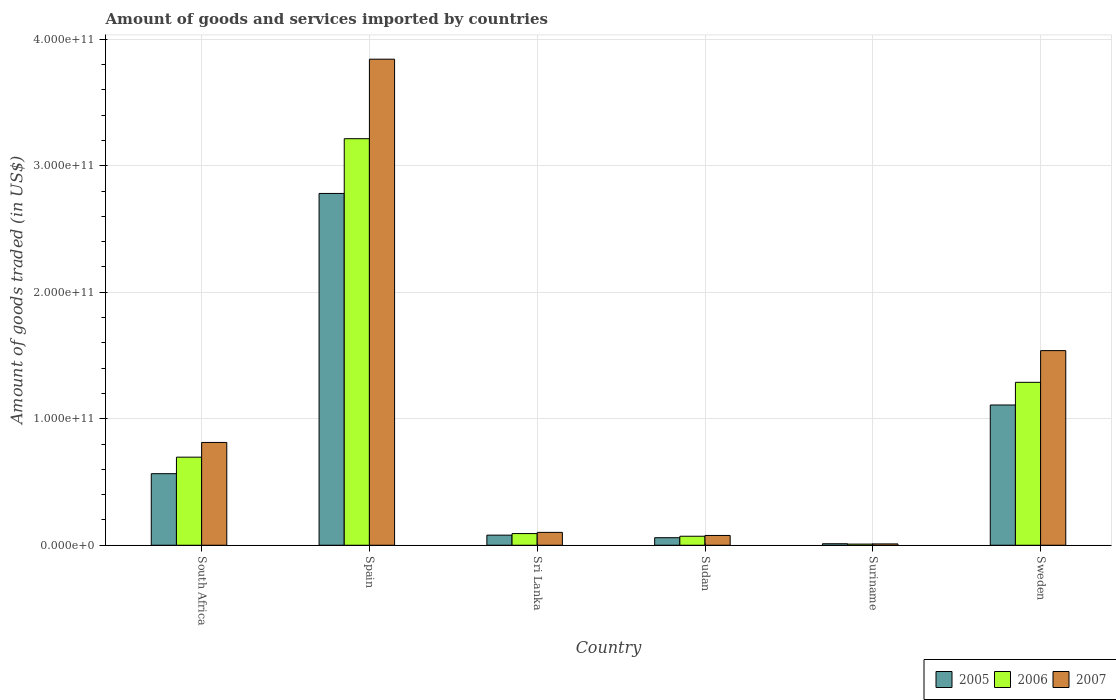Are the number of bars per tick equal to the number of legend labels?
Your answer should be very brief. Yes. How many bars are there on the 3rd tick from the left?
Provide a succinct answer. 3. What is the label of the 2nd group of bars from the left?
Offer a very short reply. Spain. In how many cases, is the number of bars for a given country not equal to the number of legend labels?
Give a very brief answer. 0. What is the total amount of goods and services imported in 2007 in Sudan?
Your answer should be very brief. 7.72e+09. Across all countries, what is the maximum total amount of goods and services imported in 2006?
Ensure brevity in your answer.  3.21e+11. Across all countries, what is the minimum total amount of goods and services imported in 2006?
Keep it short and to the point. 9.03e+08. In which country was the total amount of goods and services imported in 2005 minimum?
Ensure brevity in your answer.  Suriname. What is the total total amount of goods and services imported in 2005 in the graph?
Your answer should be compact. 4.61e+11. What is the difference between the total amount of goods and services imported in 2006 in Suriname and that in Sweden?
Your answer should be compact. -1.28e+11. What is the difference between the total amount of goods and services imported in 2007 in Suriname and the total amount of goods and services imported in 2005 in Sweden?
Your response must be concise. -1.10e+11. What is the average total amount of goods and services imported in 2006 per country?
Offer a very short reply. 8.95e+1. What is the difference between the total amount of goods and services imported of/in 2005 and total amount of goods and services imported of/in 2006 in Suriname?
Provide a short and direct response. 2.86e+08. What is the ratio of the total amount of goods and services imported in 2007 in South Africa to that in Sudan?
Your answer should be very brief. 10.52. Is the difference between the total amount of goods and services imported in 2005 in Sri Lanka and Sudan greater than the difference between the total amount of goods and services imported in 2006 in Sri Lanka and Sudan?
Give a very brief answer. No. What is the difference between the highest and the second highest total amount of goods and services imported in 2007?
Provide a succinct answer. 2.30e+11. What is the difference between the highest and the lowest total amount of goods and services imported in 2005?
Your answer should be very brief. 2.77e+11. In how many countries, is the total amount of goods and services imported in 2006 greater than the average total amount of goods and services imported in 2006 taken over all countries?
Make the answer very short. 2. Is the sum of the total amount of goods and services imported in 2005 in Sudan and Sweden greater than the maximum total amount of goods and services imported in 2006 across all countries?
Provide a short and direct response. No. What does the 2nd bar from the left in Sudan represents?
Provide a short and direct response. 2006. How many countries are there in the graph?
Give a very brief answer. 6. What is the difference between two consecutive major ticks on the Y-axis?
Give a very brief answer. 1.00e+11. Does the graph contain any zero values?
Your answer should be very brief. No. Does the graph contain grids?
Your answer should be very brief. Yes. How many legend labels are there?
Offer a very short reply. 3. How are the legend labels stacked?
Provide a succinct answer. Horizontal. What is the title of the graph?
Offer a terse response. Amount of goods and services imported by countries. What is the label or title of the Y-axis?
Offer a very short reply. Amount of goods traded (in US$). What is the Amount of goods traded (in US$) of 2005 in South Africa?
Offer a very short reply. 5.66e+1. What is the Amount of goods traded (in US$) of 2006 in South Africa?
Give a very brief answer. 6.96e+1. What is the Amount of goods traded (in US$) in 2007 in South Africa?
Your answer should be compact. 8.13e+1. What is the Amount of goods traded (in US$) in 2005 in Spain?
Provide a short and direct response. 2.78e+11. What is the Amount of goods traded (in US$) in 2006 in Spain?
Provide a succinct answer. 3.21e+11. What is the Amount of goods traded (in US$) in 2007 in Spain?
Give a very brief answer. 3.84e+11. What is the Amount of goods traded (in US$) in 2005 in Sri Lanka?
Offer a very short reply. 7.98e+09. What is the Amount of goods traded (in US$) in 2006 in Sri Lanka?
Offer a terse response. 9.23e+09. What is the Amount of goods traded (in US$) of 2007 in Sri Lanka?
Make the answer very short. 1.02e+1. What is the Amount of goods traded (in US$) of 2005 in Sudan?
Make the answer very short. 5.95e+09. What is the Amount of goods traded (in US$) of 2006 in Sudan?
Provide a succinct answer. 7.10e+09. What is the Amount of goods traded (in US$) in 2007 in Sudan?
Provide a succinct answer. 7.72e+09. What is the Amount of goods traded (in US$) in 2005 in Suriname?
Offer a very short reply. 1.19e+09. What is the Amount of goods traded (in US$) of 2006 in Suriname?
Make the answer very short. 9.03e+08. What is the Amount of goods traded (in US$) of 2007 in Suriname?
Your answer should be compact. 1.04e+09. What is the Amount of goods traded (in US$) in 2005 in Sweden?
Your answer should be compact. 1.11e+11. What is the Amount of goods traded (in US$) in 2006 in Sweden?
Offer a very short reply. 1.29e+11. What is the Amount of goods traded (in US$) of 2007 in Sweden?
Offer a very short reply. 1.54e+11. Across all countries, what is the maximum Amount of goods traded (in US$) in 2005?
Provide a succinct answer. 2.78e+11. Across all countries, what is the maximum Amount of goods traded (in US$) of 2006?
Provide a succinct answer. 3.21e+11. Across all countries, what is the maximum Amount of goods traded (in US$) in 2007?
Provide a succinct answer. 3.84e+11. Across all countries, what is the minimum Amount of goods traded (in US$) of 2005?
Your answer should be compact. 1.19e+09. Across all countries, what is the minimum Amount of goods traded (in US$) of 2006?
Provide a short and direct response. 9.03e+08. Across all countries, what is the minimum Amount of goods traded (in US$) of 2007?
Provide a short and direct response. 1.04e+09. What is the total Amount of goods traded (in US$) of 2005 in the graph?
Offer a very short reply. 4.61e+11. What is the total Amount of goods traded (in US$) of 2006 in the graph?
Give a very brief answer. 5.37e+11. What is the total Amount of goods traded (in US$) in 2007 in the graph?
Offer a very short reply. 6.38e+11. What is the difference between the Amount of goods traded (in US$) in 2005 in South Africa and that in Spain?
Provide a short and direct response. -2.22e+11. What is the difference between the Amount of goods traded (in US$) in 2006 in South Africa and that in Spain?
Your response must be concise. -2.52e+11. What is the difference between the Amount of goods traded (in US$) of 2007 in South Africa and that in Spain?
Provide a succinct answer. -3.03e+11. What is the difference between the Amount of goods traded (in US$) in 2005 in South Africa and that in Sri Lanka?
Provide a short and direct response. 4.86e+1. What is the difference between the Amount of goods traded (in US$) in 2006 in South Africa and that in Sri Lanka?
Your answer should be compact. 6.04e+1. What is the difference between the Amount of goods traded (in US$) in 2007 in South Africa and that in Sri Lanka?
Your answer should be very brief. 7.11e+1. What is the difference between the Amount of goods traded (in US$) of 2005 in South Africa and that in Sudan?
Provide a succinct answer. 5.06e+1. What is the difference between the Amount of goods traded (in US$) in 2006 in South Africa and that in Sudan?
Your answer should be very brief. 6.25e+1. What is the difference between the Amount of goods traded (in US$) of 2007 in South Africa and that in Sudan?
Offer a terse response. 7.35e+1. What is the difference between the Amount of goods traded (in US$) of 2005 in South Africa and that in Suriname?
Provide a short and direct response. 5.54e+1. What is the difference between the Amount of goods traded (in US$) in 2006 in South Africa and that in Suriname?
Make the answer very short. 6.87e+1. What is the difference between the Amount of goods traded (in US$) of 2007 in South Africa and that in Suriname?
Make the answer very short. 8.02e+1. What is the difference between the Amount of goods traded (in US$) of 2005 in South Africa and that in Sweden?
Keep it short and to the point. -5.43e+1. What is the difference between the Amount of goods traded (in US$) in 2006 in South Africa and that in Sweden?
Offer a very short reply. -5.92e+1. What is the difference between the Amount of goods traded (in US$) of 2007 in South Africa and that in Sweden?
Ensure brevity in your answer.  -7.26e+1. What is the difference between the Amount of goods traded (in US$) in 2005 in Spain and that in Sri Lanka?
Your answer should be compact. 2.70e+11. What is the difference between the Amount of goods traded (in US$) in 2006 in Spain and that in Sri Lanka?
Keep it short and to the point. 3.12e+11. What is the difference between the Amount of goods traded (in US$) of 2007 in Spain and that in Sri Lanka?
Provide a succinct answer. 3.74e+11. What is the difference between the Amount of goods traded (in US$) in 2005 in Spain and that in Sudan?
Your answer should be compact. 2.72e+11. What is the difference between the Amount of goods traded (in US$) in 2006 in Spain and that in Sudan?
Ensure brevity in your answer.  3.14e+11. What is the difference between the Amount of goods traded (in US$) of 2007 in Spain and that in Sudan?
Your response must be concise. 3.77e+11. What is the difference between the Amount of goods traded (in US$) in 2005 in Spain and that in Suriname?
Offer a terse response. 2.77e+11. What is the difference between the Amount of goods traded (in US$) of 2006 in Spain and that in Suriname?
Ensure brevity in your answer.  3.20e+11. What is the difference between the Amount of goods traded (in US$) in 2007 in Spain and that in Suriname?
Your response must be concise. 3.83e+11. What is the difference between the Amount of goods traded (in US$) of 2005 in Spain and that in Sweden?
Keep it short and to the point. 1.67e+11. What is the difference between the Amount of goods traded (in US$) in 2006 in Spain and that in Sweden?
Ensure brevity in your answer.  1.93e+11. What is the difference between the Amount of goods traded (in US$) of 2007 in Spain and that in Sweden?
Keep it short and to the point. 2.30e+11. What is the difference between the Amount of goods traded (in US$) of 2005 in Sri Lanka and that in Sudan?
Make the answer very short. 2.03e+09. What is the difference between the Amount of goods traded (in US$) in 2006 in Sri Lanka and that in Sudan?
Offer a very short reply. 2.12e+09. What is the difference between the Amount of goods traded (in US$) of 2007 in Sri Lanka and that in Sudan?
Your answer should be very brief. 2.44e+09. What is the difference between the Amount of goods traded (in US$) of 2005 in Sri Lanka and that in Suriname?
Keep it short and to the point. 6.79e+09. What is the difference between the Amount of goods traded (in US$) of 2006 in Sri Lanka and that in Suriname?
Your answer should be very brief. 8.33e+09. What is the difference between the Amount of goods traded (in US$) of 2007 in Sri Lanka and that in Suriname?
Make the answer very short. 9.12e+09. What is the difference between the Amount of goods traded (in US$) of 2005 in Sri Lanka and that in Sweden?
Offer a very short reply. -1.03e+11. What is the difference between the Amount of goods traded (in US$) of 2006 in Sri Lanka and that in Sweden?
Offer a very short reply. -1.20e+11. What is the difference between the Amount of goods traded (in US$) in 2007 in Sri Lanka and that in Sweden?
Make the answer very short. -1.44e+11. What is the difference between the Amount of goods traded (in US$) in 2005 in Sudan and that in Suriname?
Your answer should be very brief. 4.76e+09. What is the difference between the Amount of goods traded (in US$) of 2006 in Sudan and that in Suriname?
Provide a succinct answer. 6.20e+09. What is the difference between the Amount of goods traded (in US$) in 2007 in Sudan and that in Suriname?
Your answer should be compact. 6.68e+09. What is the difference between the Amount of goods traded (in US$) in 2005 in Sudan and that in Sweden?
Keep it short and to the point. -1.05e+11. What is the difference between the Amount of goods traded (in US$) of 2006 in Sudan and that in Sweden?
Offer a very short reply. -1.22e+11. What is the difference between the Amount of goods traded (in US$) in 2007 in Sudan and that in Sweden?
Your response must be concise. -1.46e+11. What is the difference between the Amount of goods traded (in US$) in 2005 in Suriname and that in Sweden?
Offer a terse response. -1.10e+11. What is the difference between the Amount of goods traded (in US$) of 2006 in Suriname and that in Sweden?
Your answer should be very brief. -1.28e+11. What is the difference between the Amount of goods traded (in US$) in 2007 in Suriname and that in Sweden?
Ensure brevity in your answer.  -1.53e+11. What is the difference between the Amount of goods traded (in US$) in 2005 in South Africa and the Amount of goods traded (in US$) in 2006 in Spain?
Offer a terse response. -2.65e+11. What is the difference between the Amount of goods traded (in US$) in 2005 in South Africa and the Amount of goods traded (in US$) in 2007 in Spain?
Offer a very short reply. -3.28e+11. What is the difference between the Amount of goods traded (in US$) of 2006 in South Africa and the Amount of goods traded (in US$) of 2007 in Spain?
Keep it short and to the point. -3.15e+11. What is the difference between the Amount of goods traded (in US$) of 2005 in South Africa and the Amount of goods traded (in US$) of 2006 in Sri Lanka?
Provide a succinct answer. 4.73e+1. What is the difference between the Amount of goods traded (in US$) in 2005 in South Africa and the Amount of goods traded (in US$) in 2007 in Sri Lanka?
Provide a succinct answer. 4.64e+1. What is the difference between the Amount of goods traded (in US$) in 2006 in South Africa and the Amount of goods traded (in US$) in 2007 in Sri Lanka?
Your answer should be very brief. 5.95e+1. What is the difference between the Amount of goods traded (in US$) of 2005 in South Africa and the Amount of goods traded (in US$) of 2006 in Sudan?
Your answer should be compact. 4.95e+1. What is the difference between the Amount of goods traded (in US$) in 2005 in South Africa and the Amount of goods traded (in US$) in 2007 in Sudan?
Ensure brevity in your answer.  4.88e+1. What is the difference between the Amount of goods traded (in US$) in 2006 in South Africa and the Amount of goods traded (in US$) in 2007 in Sudan?
Your response must be concise. 6.19e+1. What is the difference between the Amount of goods traded (in US$) of 2005 in South Africa and the Amount of goods traded (in US$) of 2006 in Suriname?
Give a very brief answer. 5.57e+1. What is the difference between the Amount of goods traded (in US$) of 2005 in South Africa and the Amount of goods traded (in US$) of 2007 in Suriname?
Offer a very short reply. 5.55e+1. What is the difference between the Amount of goods traded (in US$) of 2006 in South Africa and the Amount of goods traded (in US$) of 2007 in Suriname?
Offer a terse response. 6.86e+1. What is the difference between the Amount of goods traded (in US$) of 2005 in South Africa and the Amount of goods traded (in US$) of 2006 in Sweden?
Offer a very short reply. -7.22e+1. What is the difference between the Amount of goods traded (in US$) in 2005 in South Africa and the Amount of goods traded (in US$) in 2007 in Sweden?
Give a very brief answer. -9.73e+1. What is the difference between the Amount of goods traded (in US$) in 2006 in South Africa and the Amount of goods traded (in US$) in 2007 in Sweden?
Your answer should be compact. -8.42e+1. What is the difference between the Amount of goods traded (in US$) of 2005 in Spain and the Amount of goods traded (in US$) of 2006 in Sri Lanka?
Provide a short and direct response. 2.69e+11. What is the difference between the Amount of goods traded (in US$) in 2005 in Spain and the Amount of goods traded (in US$) in 2007 in Sri Lanka?
Offer a very short reply. 2.68e+11. What is the difference between the Amount of goods traded (in US$) in 2006 in Spain and the Amount of goods traded (in US$) in 2007 in Sri Lanka?
Provide a short and direct response. 3.11e+11. What is the difference between the Amount of goods traded (in US$) in 2005 in Spain and the Amount of goods traded (in US$) in 2006 in Sudan?
Your answer should be very brief. 2.71e+11. What is the difference between the Amount of goods traded (in US$) in 2005 in Spain and the Amount of goods traded (in US$) in 2007 in Sudan?
Keep it short and to the point. 2.70e+11. What is the difference between the Amount of goods traded (in US$) of 2006 in Spain and the Amount of goods traded (in US$) of 2007 in Sudan?
Provide a short and direct response. 3.14e+11. What is the difference between the Amount of goods traded (in US$) in 2005 in Spain and the Amount of goods traded (in US$) in 2006 in Suriname?
Ensure brevity in your answer.  2.77e+11. What is the difference between the Amount of goods traded (in US$) in 2005 in Spain and the Amount of goods traded (in US$) in 2007 in Suriname?
Your response must be concise. 2.77e+11. What is the difference between the Amount of goods traded (in US$) of 2006 in Spain and the Amount of goods traded (in US$) of 2007 in Suriname?
Provide a succinct answer. 3.20e+11. What is the difference between the Amount of goods traded (in US$) of 2005 in Spain and the Amount of goods traded (in US$) of 2006 in Sweden?
Your response must be concise. 1.49e+11. What is the difference between the Amount of goods traded (in US$) of 2005 in Spain and the Amount of goods traded (in US$) of 2007 in Sweden?
Ensure brevity in your answer.  1.24e+11. What is the difference between the Amount of goods traded (in US$) in 2006 in Spain and the Amount of goods traded (in US$) in 2007 in Sweden?
Offer a terse response. 1.68e+11. What is the difference between the Amount of goods traded (in US$) in 2005 in Sri Lanka and the Amount of goods traded (in US$) in 2006 in Sudan?
Offer a very short reply. 8.72e+08. What is the difference between the Amount of goods traded (in US$) of 2005 in Sri Lanka and the Amount of goods traded (in US$) of 2007 in Sudan?
Provide a succinct answer. 2.54e+08. What is the difference between the Amount of goods traded (in US$) of 2006 in Sri Lanka and the Amount of goods traded (in US$) of 2007 in Sudan?
Provide a succinct answer. 1.51e+09. What is the difference between the Amount of goods traded (in US$) of 2005 in Sri Lanka and the Amount of goods traded (in US$) of 2006 in Suriname?
Provide a succinct answer. 7.07e+09. What is the difference between the Amount of goods traded (in US$) of 2005 in Sri Lanka and the Amount of goods traded (in US$) of 2007 in Suriname?
Offer a very short reply. 6.93e+09. What is the difference between the Amount of goods traded (in US$) in 2006 in Sri Lanka and the Amount of goods traded (in US$) in 2007 in Suriname?
Provide a short and direct response. 8.18e+09. What is the difference between the Amount of goods traded (in US$) in 2005 in Sri Lanka and the Amount of goods traded (in US$) in 2006 in Sweden?
Your answer should be very brief. -1.21e+11. What is the difference between the Amount of goods traded (in US$) of 2005 in Sri Lanka and the Amount of goods traded (in US$) of 2007 in Sweden?
Provide a succinct answer. -1.46e+11. What is the difference between the Amount of goods traded (in US$) of 2006 in Sri Lanka and the Amount of goods traded (in US$) of 2007 in Sweden?
Provide a succinct answer. -1.45e+11. What is the difference between the Amount of goods traded (in US$) in 2005 in Sudan and the Amount of goods traded (in US$) in 2006 in Suriname?
Your answer should be very brief. 5.04e+09. What is the difference between the Amount of goods traded (in US$) in 2005 in Sudan and the Amount of goods traded (in US$) in 2007 in Suriname?
Provide a succinct answer. 4.90e+09. What is the difference between the Amount of goods traded (in US$) in 2006 in Sudan and the Amount of goods traded (in US$) in 2007 in Suriname?
Give a very brief answer. 6.06e+09. What is the difference between the Amount of goods traded (in US$) in 2005 in Sudan and the Amount of goods traded (in US$) in 2006 in Sweden?
Provide a succinct answer. -1.23e+11. What is the difference between the Amount of goods traded (in US$) in 2005 in Sudan and the Amount of goods traded (in US$) in 2007 in Sweden?
Offer a very short reply. -1.48e+11. What is the difference between the Amount of goods traded (in US$) in 2006 in Sudan and the Amount of goods traded (in US$) in 2007 in Sweden?
Your response must be concise. -1.47e+11. What is the difference between the Amount of goods traded (in US$) in 2005 in Suriname and the Amount of goods traded (in US$) in 2006 in Sweden?
Give a very brief answer. -1.28e+11. What is the difference between the Amount of goods traded (in US$) of 2005 in Suriname and the Amount of goods traded (in US$) of 2007 in Sweden?
Provide a short and direct response. -1.53e+11. What is the difference between the Amount of goods traded (in US$) in 2006 in Suriname and the Amount of goods traded (in US$) in 2007 in Sweden?
Give a very brief answer. -1.53e+11. What is the average Amount of goods traded (in US$) in 2005 per country?
Offer a terse response. 7.68e+1. What is the average Amount of goods traded (in US$) in 2006 per country?
Your answer should be compact. 8.95e+1. What is the average Amount of goods traded (in US$) in 2007 per country?
Offer a terse response. 1.06e+11. What is the difference between the Amount of goods traded (in US$) of 2005 and Amount of goods traded (in US$) of 2006 in South Africa?
Provide a succinct answer. -1.31e+1. What is the difference between the Amount of goods traded (in US$) of 2005 and Amount of goods traded (in US$) of 2007 in South Africa?
Give a very brief answer. -2.47e+1. What is the difference between the Amount of goods traded (in US$) in 2006 and Amount of goods traded (in US$) in 2007 in South Africa?
Ensure brevity in your answer.  -1.16e+1. What is the difference between the Amount of goods traded (in US$) of 2005 and Amount of goods traded (in US$) of 2006 in Spain?
Your answer should be compact. -4.33e+1. What is the difference between the Amount of goods traded (in US$) in 2005 and Amount of goods traded (in US$) in 2007 in Spain?
Your response must be concise. -1.06e+11. What is the difference between the Amount of goods traded (in US$) of 2006 and Amount of goods traded (in US$) of 2007 in Spain?
Offer a terse response. -6.29e+1. What is the difference between the Amount of goods traded (in US$) in 2005 and Amount of goods traded (in US$) in 2006 in Sri Lanka?
Provide a succinct answer. -1.25e+09. What is the difference between the Amount of goods traded (in US$) in 2005 and Amount of goods traded (in US$) in 2007 in Sri Lanka?
Ensure brevity in your answer.  -2.19e+09. What is the difference between the Amount of goods traded (in US$) of 2006 and Amount of goods traded (in US$) of 2007 in Sri Lanka?
Make the answer very short. -9.39e+08. What is the difference between the Amount of goods traded (in US$) in 2005 and Amount of goods traded (in US$) in 2006 in Sudan?
Offer a very short reply. -1.16e+09. What is the difference between the Amount of goods traded (in US$) in 2005 and Amount of goods traded (in US$) in 2007 in Sudan?
Your answer should be very brief. -1.78e+09. What is the difference between the Amount of goods traded (in US$) in 2006 and Amount of goods traded (in US$) in 2007 in Sudan?
Your answer should be very brief. -6.18e+08. What is the difference between the Amount of goods traded (in US$) in 2005 and Amount of goods traded (in US$) in 2006 in Suriname?
Offer a terse response. 2.86e+08. What is the difference between the Amount of goods traded (in US$) of 2005 and Amount of goods traded (in US$) of 2007 in Suriname?
Your answer should be compact. 1.44e+08. What is the difference between the Amount of goods traded (in US$) of 2006 and Amount of goods traded (in US$) of 2007 in Suriname?
Provide a succinct answer. -1.42e+08. What is the difference between the Amount of goods traded (in US$) in 2005 and Amount of goods traded (in US$) in 2006 in Sweden?
Provide a succinct answer. -1.79e+1. What is the difference between the Amount of goods traded (in US$) in 2005 and Amount of goods traded (in US$) in 2007 in Sweden?
Keep it short and to the point. -4.30e+1. What is the difference between the Amount of goods traded (in US$) of 2006 and Amount of goods traded (in US$) of 2007 in Sweden?
Provide a succinct answer. -2.51e+1. What is the ratio of the Amount of goods traded (in US$) of 2005 in South Africa to that in Spain?
Your response must be concise. 0.2. What is the ratio of the Amount of goods traded (in US$) of 2006 in South Africa to that in Spain?
Keep it short and to the point. 0.22. What is the ratio of the Amount of goods traded (in US$) in 2007 in South Africa to that in Spain?
Make the answer very short. 0.21. What is the ratio of the Amount of goods traded (in US$) in 2005 in South Africa to that in Sri Lanka?
Make the answer very short. 7.09. What is the ratio of the Amount of goods traded (in US$) in 2006 in South Africa to that in Sri Lanka?
Ensure brevity in your answer.  7.55. What is the ratio of the Amount of goods traded (in US$) in 2007 in South Africa to that in Sri Lanka?
Provide a succinct answer. 7.99. What is the ratio of the Amount of goods traded (in US$) of 2005 in South Africa to that in Sudan?
Your answer should be compact. 9.51. What is the ratio of the Amount of goods traded (in US$) in 2006 in South Africa to that in Sudan?
Keep it short and to the point. 9.8. What is the ratio of the Amount of goods traded (in US$) in 2007 in South Africa to that in Sudan?
Ensure brevity in your answer.  10.52. What is the ratio of the Amount of goods traded (in US$) in 2005 in South Africa to that in Suriname?
Your response must be concise. 47.58. What is the ratio of the Amount of goods traded (in US$) of 2006 in South Africa to that in Suriname?
Your answer should be compact. 77.14. What is the ratio of the Amount of goods traded (in US$) in 2007 in South Africa to that in Suriname?
Give a very brief answer. 77.78. What is the ratio of the Amount of goods traded (in US$) in 2005 in South Africa to that in Sweden?
Your answer should be very brief. 0.51. What is the ratio of the Amount of goods traded (in US$) of 2006 in South Africa to that in Sweden?
Keep it short and to the point. 0.54. What is the ratio of the Amount of goods traded (in US$) in 2007 in South Africa to that in Sweden?
Provide a short and direct response. 0.53. What is the ratio of the Amount of goods traded (in US$) in 2005 in Spain to that in Sri Lanka?
Your answer should be very brief. 34.86. What is the ratio of the Amount of goods traded (in US$) of 2006 in Spain to that in Sri Lanka?
Your answer should be compact. 34.83. What is the ratio of the Amount of goods traded (in US$) in 2007 in Spain to that in Sri Lanka?
Give a very brief answer. 37.79. What is the ratio of the Amount of goods traded (in US$) in 2005 in Spain to that in Sudan?
Make the answer very short. 46.77. What is the ratio of the Amount of goods traded (in US$) of 2006 in Spain to that in Sudan?
Offer a very short reply. 45.23. What is the ratio of the Amount of goods traded (in US$) in 2007 in Spain to that in Sudan?
Give a very brief answer. 49.76. What is the ratio of the Amount of goods traded (in US$) of 2005 in Spain to that in Suriname?
Offer a very short reply. 233.87. What is the ratio of the Amount of goods traded (in US$) of 2006 in Spain to that in Suriname?
Your answer should be compact. 356.06. What is the ratio of the Amount of goods traded (in US$) in 2007 in Spain to that in Suriname?
Your answer should be compact. 367.76. What is the ratio of the Amount of goods traded (in US$) of 2005 in Spain to that in Sweden?
Provide a short and direct response. 2.51. What is the ratio of the Amount of goods traded (in US$) of 2006 in Spain to that in Sweden?
Provide a succinct answer. 2.5. What is the ratio of the Amount of goods traded (in US$) of 2007 in Spain to that in Sweden?
Your response must be concise. 2.5. What is the ratio of the Amount of goods traded (in US$) in 2005 in Sri Lanka to that in Sudan?
Your answer should be compact. 1.34. What is the ratio of the Amount of goods traded (in US$) in 2006 in Sri Lanka to that in Sudan?
Make the answer very short. 1.3. What is the ratio of the Amount of goods traded (in US$) in 2007 in Sri Lanka to that in Sudan?
Provide a short and direct response. 1.32. What is the ratio of the Amount of goods traded (in US$) of 2005 in Sri Lanka to that in Suriname?
Ensure brevity in your answer.  6.71. What is the ratio of the Amount of goods traded (in US$) of 2006 in Sri Lanka to that in Suriname?
Keep it short and to the point. 10.22. What is the ratio of the Amount of goods traded (in US$) of 2007 in Sri Lanka to that in Suriname?
Your answer should be compact. 9.73. What is the ratio of the Amount of goods traded (in US$) of 2005 in Sri Lanka to that in Sweden?
Provide a succinct answer. 0.07. What is the ratio of the Amount of goods traded (in US$) of 2006 in Sri Lanka to that in Sweden?
Ensure brevity in your answer.  0.07. What is the ratio of the Amount of goods traded (in US$) of 2007 in Sri Lanka to that in Sweden?
Make the answer very short. 0.07. What is the ratio of the Amount of goods traded (in US$) of 2005 in Sudan to that in Suriname?
Offer a very short reply. 5. What is the ratio of the Amount of goods traded (in US$) in 2006 in Sudan to that in Suriname?
Provide a short and direct response. 7.87. What is the ratio of the Amount of goods traded (in US$) of 2007 in Sudan to that in Suriname?
Ensure brevity in your answer.  7.39. What is the ratio of the Amount of goods traded (in US$) in 2005 in Sudan to that in Sweden?
Ensure brevity in your answer.  0.05. What is the ratio of the Amount of goods traded (in US$) in 2006 in Sudan to that in Sweden?
Ensure brevity in your answer.  0.06. What is the ratio of the Amount of goods traded (in US$) of 2007 in Sudan to that in Sweden?
Offer a terse response. 0.05. What is the ratio of the Amount of goods traded (in US$) of 2005 in Suriname to that in Sweden?
Your response must be concise. 0.01. What is the ratio of the Amount of goods traded (in US$) in 2006 in Suriname to that in Sweden?
Give a very brief answer. 0.01. What is the ratio of the Amount of goods traded (in US$) of 2007 in Suriname to that in Sweden?
Your response must be concise. 0.01. What is the difference between the highest and the second highest Amount of goods traded (in US$) of 2005?
Your response must be concise. 1.67e+11. What is the difference between the highest and the second highest Amount of goods traded (in US$) of 2006?
Provide a short and direct response. 1.93e+11. What is the difference between the highest and the second highest Amount of goods traded (in US$) in 2007?
Provide a succinct answer. 2.30e+11. What is the difference between the highest and the lowest Amount of goods traded (in US$) of 2005?
Offer a very short reply. 2.77e+11. What is the difference between the highest and the lowest Amount of goods traded (in US$) in 2006?
Offer a very short reply. 3.20e+11. What is the difference between the highest and the lowest Amount of goods traded (in US$) of 2007?
Ensure brevity in your answer.  3.83e+11. 